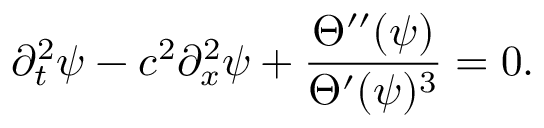<formula> <loc_0><loc_0><loc_500><loc_500>\partial _ { t } ^ { 2 } \psi - c ^ { 2 } \partial _ { x } ^ { 2 } \psi + \frac { \Theta ^ { \prime \prime } ( \psi ) } { \Theta ^ { \prime } ( \psi ) ^ { 3 } } = 0 .</formula> 